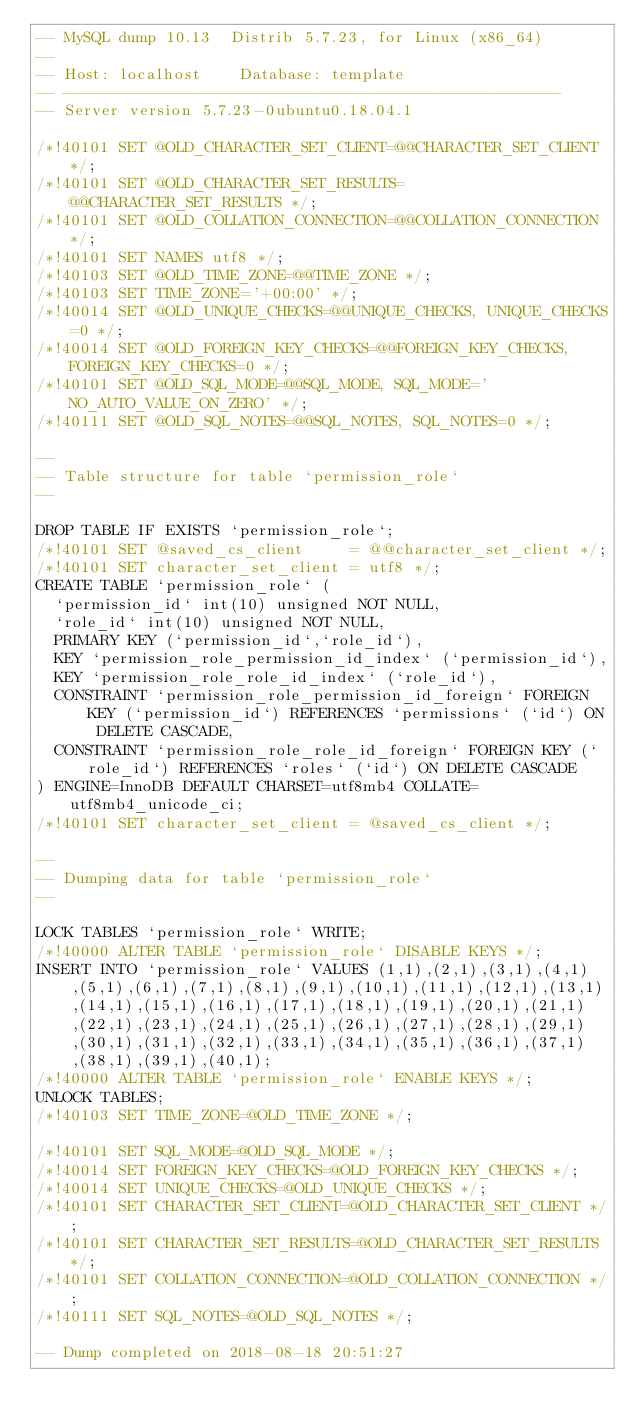Convert code to text. <code><loc_0><loc_0><loc_500><loc_500><_SQL_>-- MySQL dump 10.13  Distrib 5.7.23, for Linux (x86_64)
--
-- Host: localhost    Database: template
-- ------------------------------------------------------
-- Server version	5.7.23-0ubuntu0.18.04.1

/*!40101 SET @OLD_CHARACTER_SET_CLIENT=@@CHARACTER_SET_CLIENT */;
/*!40101 SET @OLD_CHARACTER_SET_RESULTS=@@CHARACTER_SET_RESULTS */;
/*!40101 SET @OLD_COLLATION_CONNECTION=@@COLLATION_CONNECTION */;
/*!40101 SET NAMES utf8 */;
/*!40103 SET @OLD_TIME_ZONE=@@TIME_ZONE */;
/*!40103 SET TIME_ZONE='+00:00' */;
/*!40014 SET @OLD_UNIQUE_CHECKS=@@UNIQUE_CHECKS, UNIQUE_CHECKS=0 */;
/*!40014 SET @OLD_FOREIGN_KEY_CHECKS=@@FOREIGN_KEY_CHECKS, FOREIGN_KEY_CHECKS=0 */;
/*!40101 SET @OLD_SQL_MODE=@@SQL_MODE, SQL_MODE='NO_AUTO_VALUE_ON_ZERO' */;
/*!40111 SET @OLD_SQL_NOTES=@@SQL_NOTES, SQL_NOTES=0 */;

--
-- Table structure for table `permission_role`
--

DROP TABLE IF EXISTS `permission_role`;
/*!40101 SET @saved_cs_client     = @@character_set_client */;
/*!40101 SET character_set_client = utf8 */;
CREATE TABLE `permission_role` (
  `permission_id` int(10) unsigned NOT NULL,
  `role_id` int(10) unsigned NOT NULL,
  PRIMARY KEY (`permission_id`,`role_id`),
  KEY `permission_role_permission_id_index` (`permission_id`),
  KEY `permission_role_role_id_index` (`role_id`),
  CONSTRAINT `permission_role_permission_id_foreign` FOREIGN KEY (`permission_id`) REFERENCES `permissions` (`id`) ON DELETE CASCADE,
  CONSTRAINT `permission_role_role_id_foreign` FOREIGN KEY (`role_id`) REFERENCES `roles` (`id`) ON DELETE CASCADE
) ENGINE=InnoDB DEFAULT CHARSET=utf8mb4 COLLATE=utf8mb4_unicode_ci;
/*!40101 SET character_set_client = @saved_cs_client */;

--
-- Dumping data for table `permission_role`
--

LOCK TABLES `permission_role` WRITE;
/*!40000 ALTER TABLE `permission_role` DISABLE KEYS */;
INSERT INTO `permission_role` VALUES (1,1),(2,1),(3,1),(4,1),(5,1),(6,1),(7,1),(8,1),(9,1),(10,1),(11,1),(12,1),(13,1),(14,1),(15,1),(16,1),(17,1),(18,1),(19,1),(20,1),(21,1),(22,1),(23,1),(24,1),(25,1),(26,1),(27,1),(28,1),(29,1),(30,1),(31,1),(32,1),(33,1),(34,1),(35,1),(36,1),(37,1),(38,1),(39,1),(40,1);
/*!40000 ALTER TABLE `permission_role` ENABLE KEYS */;
UNLOCK TABLES;
/*!40103 SET TIME_ZONE=@OLD_TIME_ZONE */;

/*!40101 SET SQL_MODE=@OLD_SQL_MODE */;
/*!40014 SET FOREIGN_KEY_CHECKS=@OLD_FOREIGN_KEY_CHECKS */;
/*!40014 SET UNIQUE_CHECKS=@OLD_UNIQUE_CHECKS */;
/*!40101 SET CHARACTER_SET_CLIENT=@OLD_CHARACTER_SET_CLIENT */;
/*!40101 SET CHARACTER_SET_RESULTS=@OLD_CHARACTER_SET_RESULTS */;
/*!40101 SET COLLATION_CONNECTION=@OLD_COLLATION_CONNECTION */;
/*!40111 SET SQL_NOTES=@OLD_SQL_NOTES */;

-- Dump completed on 2018-08-18 20:51:27
</code> 